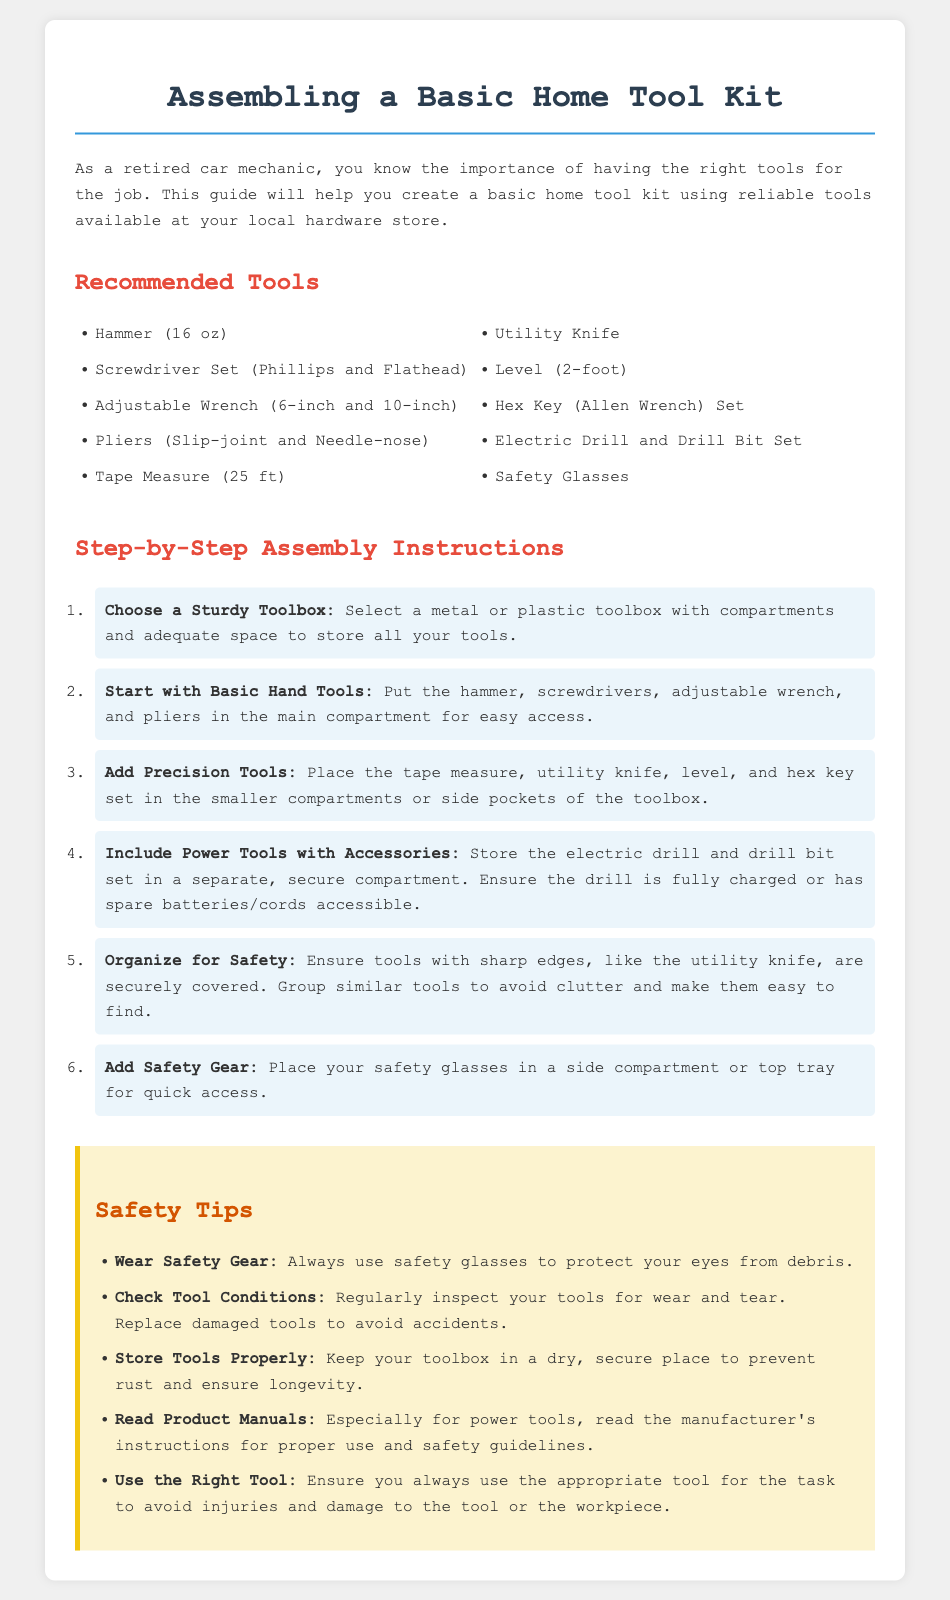What is the first step in assembling the tool kit? The first step is to choose a sturdy toolbox, as outlined in the instructions.
Answer: Choose a Sturdy Toolbox How many inches is the adjustable wrench recommended? The document specifies two sizes for the adjustable wrench: 6-inch and 10-inch.
Answer: 6-inch and 10-inch What should you do with tools that have sharp edges? The document recommends securely covering tools with sharp edges to ensure safety.
Answer: Securely covered Which safety gear is mentioned in the toolkit assembly guide? Safety glasses are specifically mentioned as essential safety gear in the document.
Answer: Safety Glasses What type of toolbox is recommended? The instructions suggest selecting a metal or plastic toolbox for storing the tools.
Answer: Metal or plastic toolbox What is the maximum distance for the tape measure listed? The document states that a 25 ft tape measure is recommended for the home tool kit.
Answer: 25 ft What action should be taken regarding damaged tools? The guide emphasizes the importance of replacing damaged tools to avoid accidents.
Answer: Replace damaged tools Where should you place the safety glasses for quick access? The assembly guide advises placing safety glasses in a side compartment or top tray for convenience.
Answer: Side compartment or top tray 